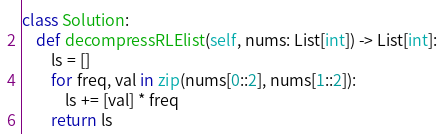<code> <loc_0><loc_0><loc_500><loc_500><_Python_>class Solution:
    def decompressRLElist(self, nums: List[int]) -> List[int]:
        ls = []
        for freq, val in zip(nums[0::2], nums[1::2]):
            ls += [val] * freq
        return ls
</code> 